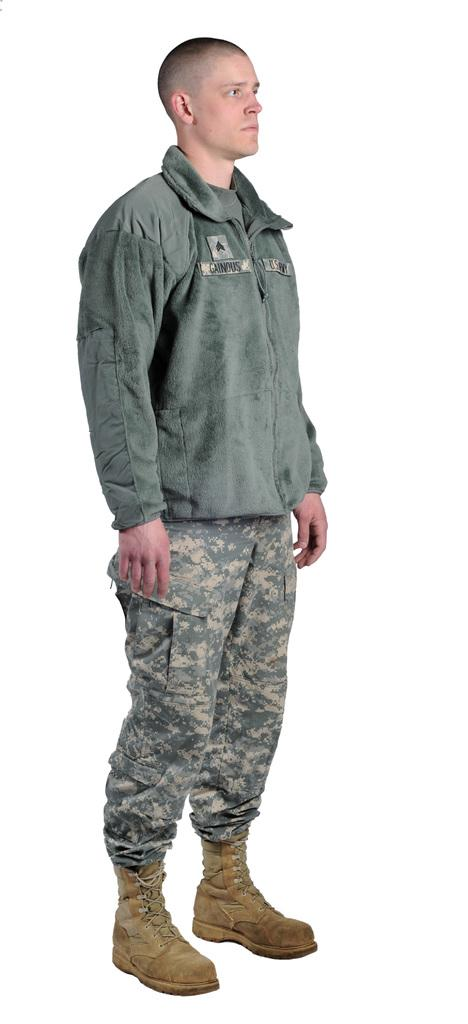What is the main subject of the image? There is a man standing in the image. What type of clothing is the man wearing? The man is wearing a jacket and camouflage pants. What color are the man's shoes? The man is wearing brown shoes. What color can be seen in the background of the image? There is a white color visible in the background of the image. What type of bells can be heard ringing in the image? There are no bells present in the image, and therefore no sound can be heard. Is there a pipe visible in the image? There is no pipe visible in the image. 